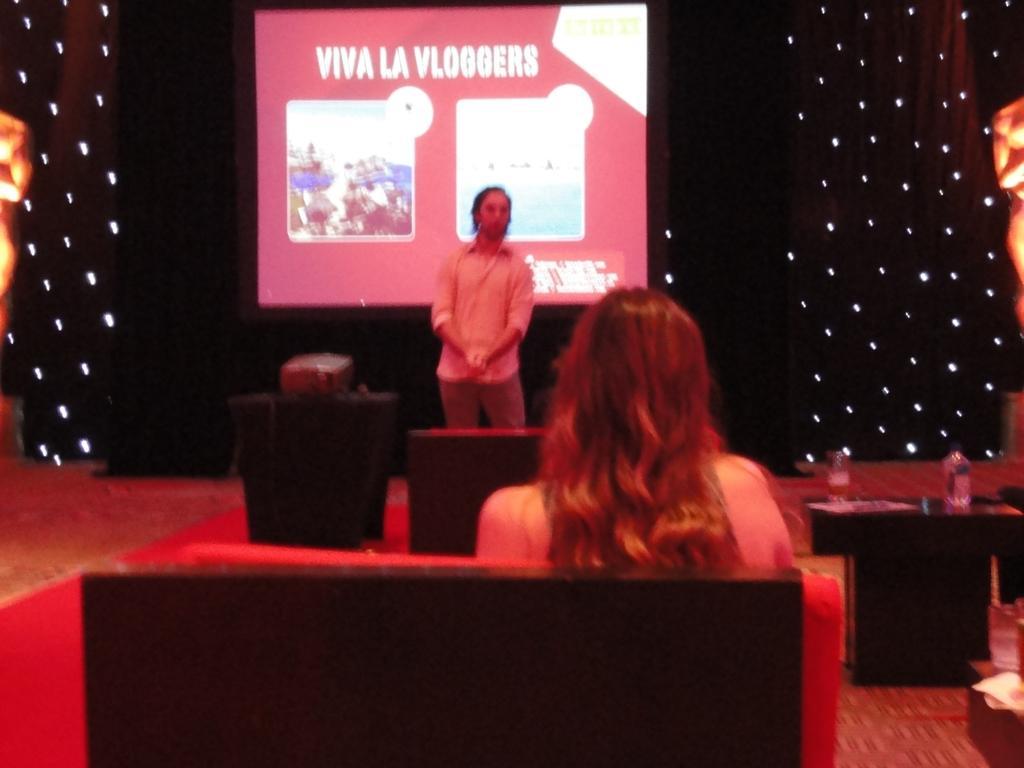Describe this image in one or two sentences. In this image I can see two people were on is sitting and one is standing. I can also see a table over here and on it I can see few bottles. In the background I can see projector screen, few sculptures and I can see number of lights. I can also see something is written over here. 